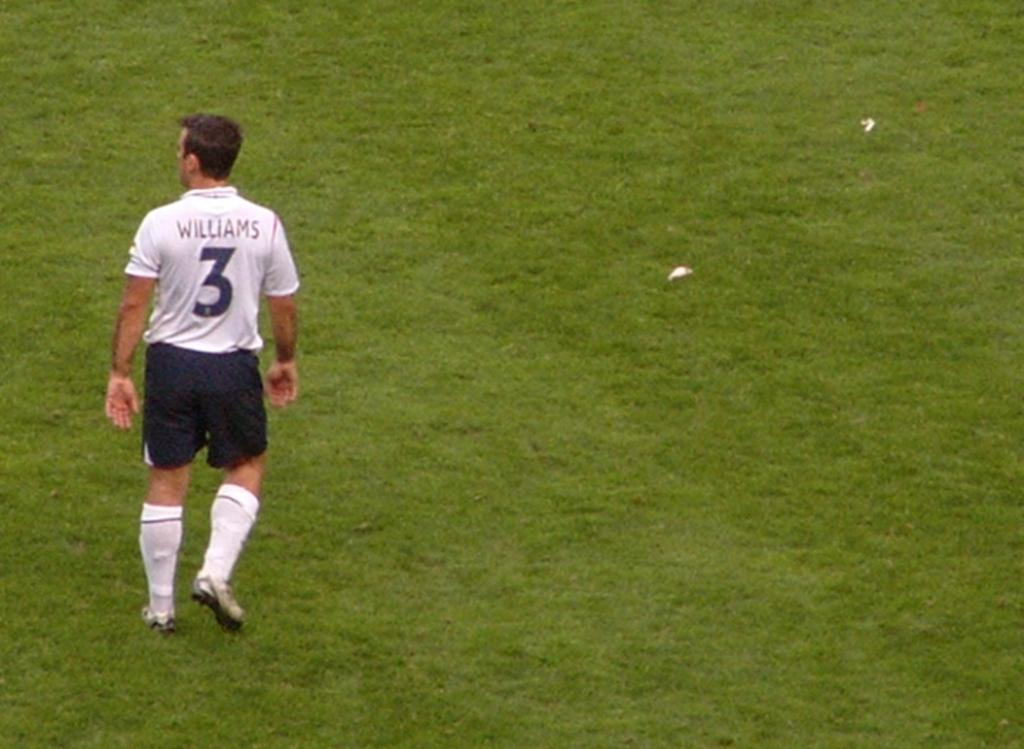<image>
Describe the image concisely. The player in the white is named Williams 